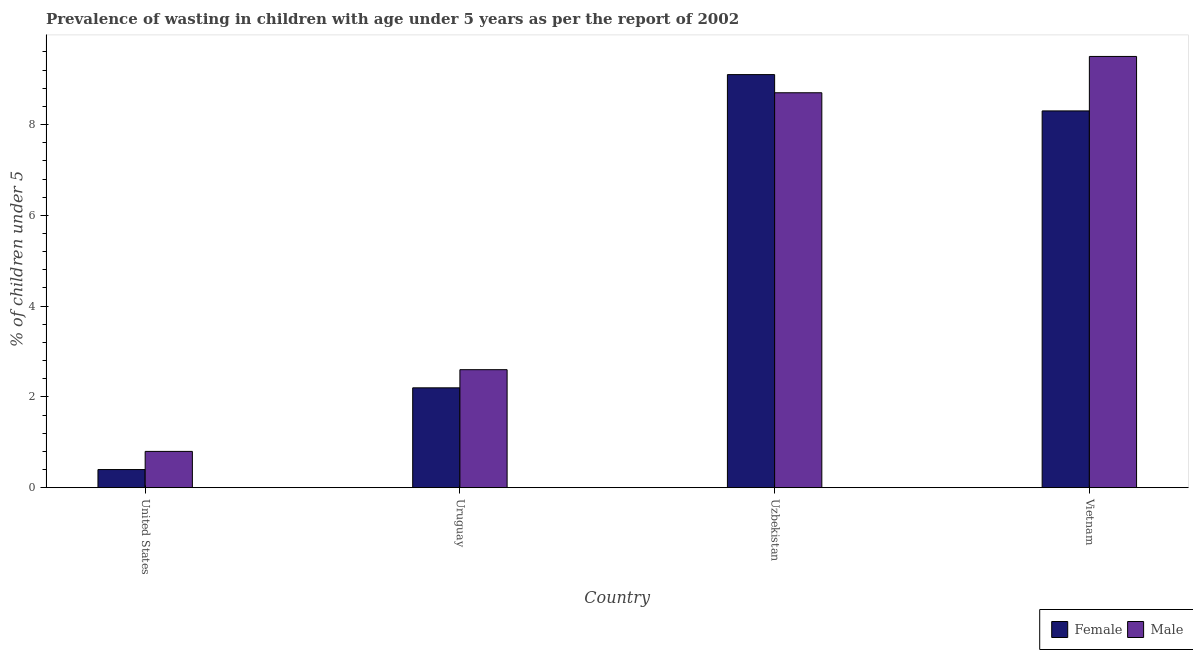Are the number of bars on each tick of the X-axis equal?
Provide a succinct answer. Yes. How many bars are there on the 1st tick from the left?
Keep it short and to the point. 2. In how many cases, is the number of bars for a given country not equal to the number of legend labels?
Make the answer very short. 0. What is the percentage of undernourished male children in Uzbekistan?
Offer a very short reply. 8.7. Across all countries, what is the maximum percentage of undernourished female children?
Your answer should be compact. 9.1. Across all countries, what is the minimum percentage of undernourished female children?
Offer a very short reply. 0.4. In which country was the percentage of undernourished female children maximum?
Your response must be concise. Uzbekistan. In which country was the percentage of undernourished female children minimum?
Your answer should be very brief. United States. What is the total percentage of undernourished female children in the graph?
Ensure brevity in your answer.  20. What is the difference between the percentage of undernourished female children in Uruguay and that in Vietnam?
Offer a terse response. -6.1. What is the difference between the percentage of undernourished male children in Vietnam and the percentage of undernourished female children in Uzbekistan?
Provide a short and direct response. 0.4. What is the average percentage of undernourished female children per country?
Give a very brief answer. 5. What is the difference between the percentage of undernourished female children and percentage of undernourished male children in United States?
Your answer should be compact. -0.4. In how many countries, is the percentage of undernourished female children greater than 5.6 %?
Ensure brevity in your answer.  2. What is the ratio of the percentage of undernourished female children in United States to that in Vietnam?
Your answer should be compact. 0.05. Is the percentage of undernourished male children in United States less than that in Uruguay?
Offer a terse response. Yes. Is the difference between the percentage of undernourished female children in United States and Uzbekistan greater than the difference between the percentage of undernourished male children in United States and Uzbekistan?
Your answer should be very brief. No. What is the difference between the highest and the second highest percentage of undernourished male children?
Provide a short and direct response. 0.8. What is the difference between the highest and the lowest percentage of undernourished female children?
Keep it short and to the point. 8.7. Are all the bars in the graph horizontal?
Give a very brief answer. No. How many countries are there in the graph?
Provide a short and direct response. 4. Are the values on the major ticks of Y-axis written in scientific E-notation?
Provide a succinct answer. No. How are the legend labels stacked?
Provide a succinct answer. Horizontal. What is the title of the graph?
Your answer should be very brief. Prevalence of wasting in children with age under 5 years as per the report of 2002. What is the label or title of the X-axis?
Your answer should be compact. Country. What is the label or title of the Y-axis?
Keep it short and to the point.  % of children under 5. What is the  % of children under 5 of Female in United States?
Keep it short and to the point. 0.4. What is the  % of children under 5 in Male in United States?
Your answer should be very brief. 0.8. What is the  % of children under 5 in Female in Uruguay?
Ensure brevity in your answer.  2.2. What is the  % of children under 5 of Male in Uruguay?
Make the answer very short. 2.6. What is the  % of children under 5 of Female in Uzbekistan?
Ensure brevity in your answer.  9.1. What is the  % of children under 5 in Male in Uzbekistan?
Make the answer very short. 8.7. What is the  % of children under 5 in Female in Vietnam?
Provide a short and direct response. 8.3. Across all countries, what is the maximum  % of children under 5 in Female?
Make the answer very short. 9.1. Across all countries, what is the maximum  % of children under 5 in Male?
Your answer should be compact. 9.5. Across all countries, what is the minimum  % of children under 5 in Female?
Give a very brief answer. 0.4. Across all countries, what is the minimum  % of children under 5 in Male?
Offer a very short reply. 0.8. What is the total  % of children under 5 in Female in the graph?
Offer a terse response. 20. What is the total  % of children under 5 in Male in the graph?
Your response must be concise. 21.6. What is the difference between the  % of children under 5 in Female in United States and that in Uruguay?
Make the answer very short. -1.8. What is the difference between the  % of children under 5 in Female in United States and that in Uzbekistan?
Offer a terse response. -8.7. What is the difference between the  % of children under 5 in Male in United States and that in Uzbekistan?
Give a very brief answer. -7.9. What is the difference between the  % of children under 5 in Female in Uruguay and that in Uzbekistan?
Provide a short and direct response. -6.9. What is the difference between the  % of children under 5 of Female in Uruguay and that in Vietnam?
Offer a very short reply. -6.1. What is the difference between the  % of children under 5 of Male in Uruguay and that in Vietnam?
Make the answer very short. -6.9. What is the difference between the  % of children under 5 in Female in Uzbekistan and that in Vietnam?
Make the answer very short. 0.8. What is the difference between the  % of children under 5 of Female in United States and the  % of children under 5 of Male in Uzbekistan?
Make the answer very short. -8.3. What is the difference between the  % of children under 5 of Female in United States and the  % of children under 5 of Male in Vietnam?
Your answer should be very brief. -9.1. What is the difference between the  % of children under 5 in Female in Uruguay and the  % of children under 5 in Male in Vietnam?
Provide a short and direct response. -7.3. What is the difference between the  % of children under 5 in Female in Uzbekistan and the  % of children under 5 in Male in Vietnam?
Provide a succinct answer. -0.4. What is the average  % of children under 5 of Female per country?
Your answer should be compact. 5. What is the difference between the  % of children under 5 of Female and  % of children under 5 of Male in United States?
Your response must be concise. -0.4. What is the difference between the  % of children under 5 of Female and  % of children under 5 of Male in Uruguay?
Ensure brevity in your answer.  -0.4. What is the difference between the  % of children under 5 of Female and  % of children under 5 of Male in Uzbekistan?
Offer a terse response. 0.4. What is the difference between the  % of children under 5 of Female and  % of children under 5 of Male in Vietnam?
Offer a very short reply. -1.2. What is the ratio of the  % of children under 5 in Female in United States to that in Uruguay?
Your response must be concise. 0.18. What is the ratio of the  % of children under 5 in Male in United States to that in Uruguay?
Keep it short and to the point. 0.31. What is the ratio of the  % of children under 5 in Female in United States to that in Uzbekistan?
Keep it short and to the point. 0.04. What is the ratio of the  % of children under 5 in Male in United States to that in Uzbekistan?
Your answer should be compact. 0.09. What is the ratio of the  % of children under 5 of Female in United States to that in Vietnam?
Your response must be concise. 0.05. What is the ratio of the  % of children under 5 in Male in United States to that in Vietnam?
Make the answer very short. 0.08. What is the ratio of the  % of children under 5 in Female in Uruguay to that in Uzbekistan?
Provide a succinct answer. 0.24. What is the ratio of the  % of children under 5 in Male in Uruguay to that in Uzbekistan?
Ensure brevity in your answer.  0.3. What is the ratio of the  % of children under 5 in Female in Uruguay to that in Vietnam?
Offer a very short reply. 0.27. What is the ratio of the  % of children under 5 of Male in Uruguay to that in Vietnam?
Provide a short and direct response. 0.27. What is the ratio of the  % of children under 5 of Female in Uzbekistan to that in Vietnam?
Make the answer very short. 1.1. What is the ratio of the  % of children under 5 of Male in Uzbekistan to that in Vietnam?
Your answer should be very brief. 0.92. What is the difference between the highest and the second highest  % of children under 5 of Male?
Keep it short and to the point. 0.8. 